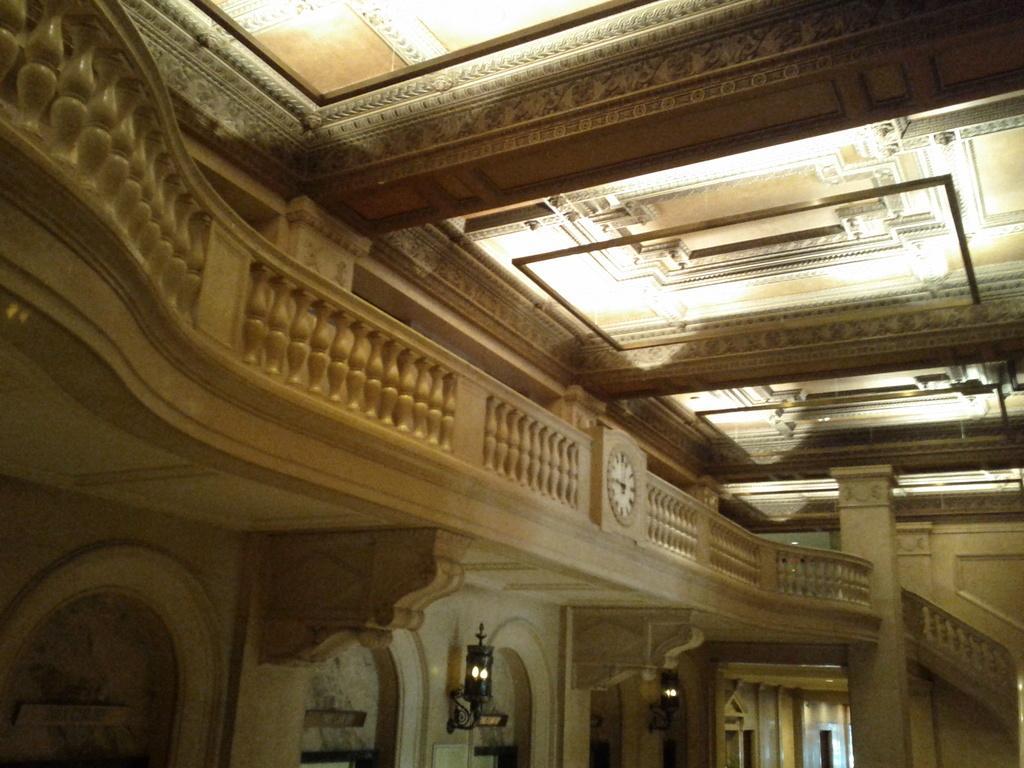How would you summarize this image in a sentence or two? In this picture I can see the inside view of the building. In the center there is a clock which is placed on this concrete fencing. At the bottom I can see some lights which are placed on the wall. At the top I can see the light beams on the roof. 